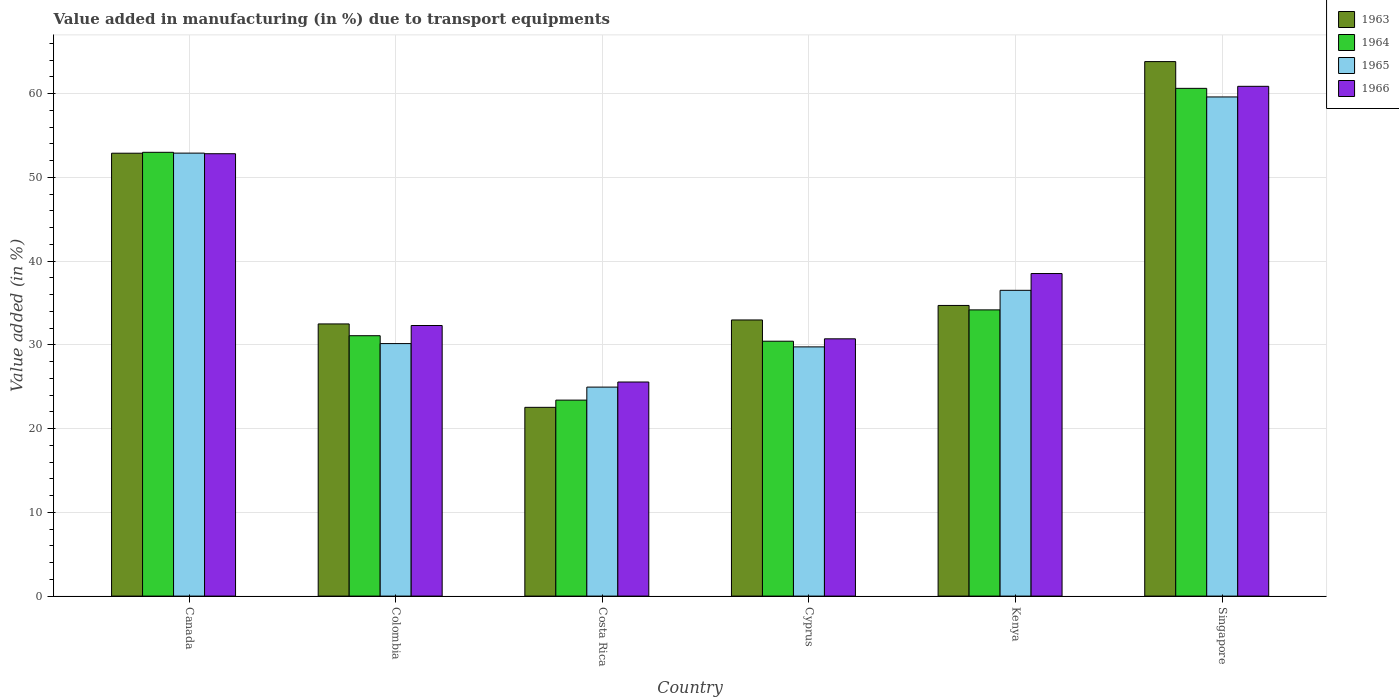How many groups of bars are there?
Your answer should be compact. 6. Are the number of bars per tick equal to the number of legend labels?
Ensure brevity in your answer.  Yes. Are the number of bars on each tick of the X-axis equal?
Your answer should be compact. Yes. How many bars are there on the 6th tick from the left?
Keep it short and to the point. 4. How many bars are there on the 5th tick from the right?
Give a very brief answer. 4. What is the label of the 2nd group of bars from the left?
Your response must be concise. Colombia. What is the percentage of value added in manufacturing due to transport equipments in 1966 in Colombia?
Provide a short and direct response. 32.3. Across all countries, what is the maximum percentage of value added in manufacturing due to transport equipments in 1965?
Keep it short and to the point. 59.59. Across all countries, what is the minimum percentage of value added in manufacturing due to transport equipments in 1963?
Offer a terse response. 22.53. In which country was the percentage of value added in manufacturing due to transport equipments in 1965 maximum?
Give a very brief answer. Singapore. What is the total percentage of value added in manufacturing due to transport equipments in 1966 in the graph?
Offer a very short reply. 240.76. What is the difference between the percentage of value added in manufacturing due to transport equipments in 1966 in Colombia and that in Singapore?
Your answer should be compact. -28.56. What is the difference between the percentage of value added in manufacturing due to transport equipments in 1966 in Costa Rica and the percentage of value added in manufacturing due to transport equipments in 1965 in Singapore?
Provide a short and direct response. -34.03. What is the average percentage of value added in manufacturing due to transport equipments in 1965 per country?
Ensure brevity in your answer.  38.97. What is the difference between the percentage of value added in manufacturing due to transport equipments of/in 1965 and percentage of value added in manufacturing due to transport equipments of/in 1966 in Kenya?
Your answer should be compact. -2. In how many countries, is the percentage of value added in manufacturing due to transport equipments in 1963 greater than 60 %?
Provide a succinct answer. 1. What is the ratio of the percentage of value added in manufacturing due to transport equipments in 1966 in Canada to that in Cyprus?
Keep it short and to the point. 1.72. Is the percentage of value added in manufacturing due to transport equipments in 1963 in Costa Rica less than that in Singapore?
Keep it short and to the point. Yes. What is the difference between the highest and the second highest percentage of value added in manufacturing due to transport equipments in 1963?
Provide a succinct answer. -18.17. What is the difference between the highest and the lowest percentage of value added in manufacturing due to transport equipments in 1965?
Provide a short and direct response. 34.64. In how many countries, is the percentage of value added in manufacturing due to transport equipments in 1965 greater than the average percentage of value added in manufacturing due to transport equipments in 1965 taken over all countries?
Offer a terse response. 2. Is the sum of the percentage of value added in manufacturing due to transport equipments in 1964 in Kenya and Singapore greater than the maximum percentage of value added in manufacturing due to transport equipments in 1963 across all countries?
Keep it short and to the point. Yes. What does the 4th bar from the left in Costa Rica represents?
Offer a terse response. 1966. What does the 3rd bar from the right in Costa Rica represents?
Give a very brief answer. 1964. Are all the bars in the graph horizontal?
Offer a terse response. No. How many countries are there in the graph?
Provide a succinct answer. 6. Are the values on the major ticks of Y-axis written in scientific E-notation?
Your answer should be very brief. No. Does the graph contain any zero values?
Offer a very short reply. No. Does the graph contain grids?
Provide a short and direct response. Yes. How many legend labels are there?
Offer a very short reply. 4. What is the title of the graph?
Provide a short and direct response. Value added in manufacturing (in %) due to transport equipments. Does "1970" appear as one of the legend labels in the graph?
Make the answer very short. No. What is the label or title of the Y-axis?
Give a very brief answer. Value added (in %). What is the Value added (in %) in 1963 in Canada?
Offer a very short reply. 52.87. What is the Value added (in %) of 1964 in Canada?
Your response must be concise. 52.98. What is the Value added (in %) in 1965 in Canada?
Your response must be concise. 52.89. What is the Value added (in %) in 1966 in Canada?
Your answer should be very brief. 52.81. What is the Value added (in %) in 1963 in Colombia?
Provide a succinct answer. 32.49. What is the Value added (in %) in 1964 in Colombia?
Your response must be concise. 31.09. What is the Value added (in %) of 1965 in Colombia?
Provide a short and direct response. 30.15. What is the Value added (in %) in 1966 in Colombia?
Keep it short and to the point. 32.3. What is the Value added (in %) of 1963 in Costa Rica?
Make the answer very short. 22.53. What is the Value added (in %) in 1964 in Costa Rica?
Ensure brevity in your answer.  23.4. What is the Value added (in %) of 1965 in Costa Rica?
Your answer should be very brief. 24.95. What is the Value added (in %) of 1966 in Costa Rica?
Your answer should be compact. 25.56. What is the Value added (in %) of 1963 in Cyprus?
Keep it short and to the point. 32.97. What is the Value added (in %) of 1964 in Cyprus?
Make the answer very short. 30.43. What is the Value added (in %) in 1965 in Cyprus?
Keep it short and to the point. 29.75. What is the Value added (in %) in 1966 in Cyprus?
Your answer should be compact. 30.72. What is the Value added (in %) of 1963 in Kenya?
Give a very brief answer. 34.7. What is the Value added (in %) of 1964 in Kenya?
Your answer should be compact. 34.17. What is the Value added (in %) in 1965 in Kenya?
Your answer should be compact. 36.5. What is the Value added (in %) in 1966 in Kenya?
Give a very brief answer. 38.51. What is the Value added (in %) of 1963 in Singapore?
Your answer should be very brief. 63.81. What is the Value added (in %) of 1964 in Singapore?
Your response must be concise. 60.62. What is the Value added (in %) of 1965 in Singapore?
Your answer should be very brief. 59.59. What is the Value added (in %) of 1966 in Singapore?
Ensure brevity in your answer.  60.86. Across all countries, what is the maximum Value added (in %) in 1963?
Provide a succinct answer. 63.81. Across all countries, what is the maximum Value added (in %) in 1964?
Your response must be concise. 60.62. Across all countries, what is the maximum Value added (in %) in 1965?
Provide a succinct answer. 59.59. Across all countries, what is the maximum Value added (in %) in 1966?
Provide a succinct answer. 60.86. Across all countries, what is the minimum Value added (in %) in 1963?
Offer a very short reply. 22.53. Across all countries, what is the minimum Value added (in %) in 1964?
Your response must be concise. 23.4. Across all countries, what is the minimum Value added (in %) in 1965?
Offer a very short reply. 24.95. Across all countries, what is the minimum Value added (in %) of 1966?
Provide a short and direct response. 25.56. What is the total Value added (in %) of 1963 in the graph?
Keep it short and to the point. 239.38. What is the total Value added (in %) in 1964 in the graph?
Offer a terse response. 232.68. What is the total Value added (in %) of 1965 in the graph?
Make the answer very short. 233.83. What is the total Value added (in %) in 1966 in the graph?
Your answer should be very brief. 240.76. What is the difference between the Value added (in %) in 1963 in Canada and that in Colombia?
Make the answer very short. 20.38. What is the difference between the Value added (in %) of 1964 in Canada and that in Colombia?
Your response must be concise. 21.9. What is the difference between the Value added (in %) in 1965 in Canada and that in Colombia?
Ensure brevity in your answer.  22.74. What is the difference between the Value added (in %) of 1966 in Canada and that in Colombia?
Your response must be concise. 20.51. What is the difference between the Value added (in %) in 1963 in Canada and that in Costa Rica?
Your answer should be very brief. 30.34. What is the difference between the Value added (in %) of 1964 in Canada and that in Costa Rica?
Ensure brevity in your answer.  29.59. What is the difference between the Value added (in %) in 1965 in Canada and that in Costa Rica?
Your answer should be compact. 27.93. What is the difference between the Value added (in %) in 1966 in Canada and that in Costa Rica?
Your response must be concise. 27.25. What is the difference between the Value added (in %) in 1963 in Canada and that in Cyprus?
Offer a terse response. 19.91. What is the difference between the Value added (in %) in 1964 in Canada and that in Cyprus?
Your response must be concise. 22.55. What is the difference between the Value added (in %) in 1965 in Canada and that in Cyprus?
Your answer should be compact. 23.13. What is the difference between the Value added (in %) of 1966 in Canada and that in Cyprus?
Ensure brevity in your answer.  22.1. What is the difference between the Value added (in %) in 1963 in Canada and that in Kenya?
Ensure brevity in your answer.  18.17. What is the difference between the Value added (in %) of 1964 in Canada and that in Kenya?
Offer a very short reply. 18.81. What is the difference between the Value added (in %) in 1965 in Canada and that in Kenya?
Provide a short and direct response. 16.38. What is the difference between the Value added (in %) in 1966 in Canada and that in Kenya?
Your response must be concise. 14.3. What is the difference between the Value added (in %) in 1963 in Canada and that in Singapore?
Your response must be concise. -10.94. What is the difference between the Value added (in %) of 1964 in Canada and that in Singapore?
Your response must be concise. -7.63. What is the difference between the Value added (in %) of 1965 in Canada and that in Singapore?
Give a very brief answer. -6.71. What is the difference between the Value added (in %) of 1966 in Canada and that in Singapore?
Give a very brief answer. -8.05. What is the difference between the Value added (in %) in 1963 in Colombia and that in Costa Rica?
Make the answer very short. 9.96. What is the difference between the Value added (in %) in 1964 in Colombia and that in Costa Rica?
Offer a terse response. 7.69. What is the difference between the Value added (in %) in 1965 in Colombia and that in Costa Rica?
Offer a terse response. 5.2. What is the difference between the Value added (in %) of 1966 in Colombia and that in Costa Rica?
Provide a short and direct response. 6.74. What is the difference between the Value added (in %) of 1963 in Colombia and that in Cyprus?
Make the answer very short. -0.47. What is the difference between the Value added (in %) of 1964 in Colombia and that in Cyprus?
Make the answer very short. 0.66. What is the difference between the Value added (in %) in 1965 in Colombia and that in Cyprus?
Your answer should be very brief. 0.39. What is the difference between the Value added (in %) of 1966 in Colombia and that in Cyprus?
Provide a short and direct response. 1.59. What is the difference between the Value added (in %) in 1963 in Colombia and that in Kenya?
Provide a short and direct response. -2.21. What is the difference between the Value added (in %) of 1964 in Colombia and that in Kenya?
Provide a succinct answer. -3.08. What is the difference between the Value added (in %) of 1965 in Colombia and that in Kenya?
Your response must be concise. -6.36. What is the difference between the Value added (in %) of 1966 in Colombia and that in Kenya?
Make the answer very short. -6.2. What is the difference between the Value added (in %) of 1963 in Colombia and that in Singapore?
Make the answer very short. -31.32. What is the difference between the Value added (in %) in 1964 in Colombia and that in Singapore?
Provide a succinct answer. -29.53. What is the difference between the Value added (in %) of 1965 in Colombia and that in Singapore?
Offer a terse response. -29.45. What is the difference between the Value added (in %) in 1966 in Colombia and that in Singapore?
Ensure brevity in your answer.  -28.56. What is the difference between the Value added (in %) of 1963 in Costa Rica and that in Cyprus?
Provide a succinct answer. -10.43. What is the difference between the Value added (in %) in 1964 in Costa Rica and that in Cyprus?
Offer a terse response. -7.03. What is the difference between the Value added (in %) of 1965 in Costa Rica and that in Cyprus?
Provide a short and direct response. -4.8. What is the difference between the Value added (in %) of 1966 in Costa Rica and that in Cyprus?
Give a very brief answer. -5.16. What is the difference between the Value added (in %) in 1963 in Costa Rica and that in Kenya?
Your answer should be compact. -12.17. What is the difference between the Value added (in %) of 1964 in Costa Rica and that in Kenya?
Offer a very short reply. -10.77. What is the difference between the Value added (in %) of 1965 in Costa Rica and that in Kenya?
Your answer should be compact. -11.55. What is the difference between the Value added (in %) in 1966 in Costa Rica and that in Kenya?
Offer a very short reply. -12.95. What is the difference between the Value added (in %) of 1963 in Costa Rica and that in Singapore?
Your answer should be very brief. -41.28. What is the difference between the Value added (in %) in 1964 in Costa Rica and that in Singapore?
Your answer should be compact. -37.22. What is the difference between the Value added (in %) of 1965 in Costa Rica and that in Singapore?
Your response must be concise. -34.64. What is the difference between the Value added (in %) in 1966 in Costa Rica and that in Singapore?
Give a very brief answer. -35.3. What is the difference between the Value added (in %) of 1963 in Cyprus and that in Kenya?
Make the answer very short. -1.73. What is the difference between the Value added (in %) in 1964 in Cyprus and that in Kenya?
Provide a short and direct response. -3.74. What is the difference between the Value added (in %) of 1965 in Cyprus and that in Kenya?
Your answer should be compact. -6.75. What is the difference between the Value added (in %) in 1966 in Cyprus and that in Kenya?
Ensure brevity in your answer.  -7.79. What is the difference between the Value added (in %) in 1963 in Cyprus and that in Singapore?
Offer a terse response. -30.84. What is the difference between the Value added (in %) in 1964 in Cyprus and that in Singapore?
Keep it short and to the point. -30.19. What is the difference between the Value added (in %) of 1965 in Cyprus and that in Singapore?
Your response must be concise. -29.84. What is the difference between the Value added (in %) in 1966 in Cyprus and that in Singapore?
Provide a succinct answer. -30.14. What is the difference between the Value added (in %) in 1963 in Kenya and that in Singapore?
Offer a terse response. -29.11. What is the difference between the Value added (in %) of 1964 in Kenya and that in Singapore?
Provide a short and direct response. -26.45. What is the difference between the Value added (in %) in 1965 in Kenya and that in Singapore?
Provide a short and direct response. -23.09. What is the difference between the Value added (in %) of 1966 in Kenya and that in Singapore?
Offer a terse response. -22.35. What is the difference between the Value added (in %) in 1963 in Canada and the Value added (in %) in 1964 in Colombia?
Provide a succinct answer. 21.79. What is the difference between the Value added (in %) in 1963 in Canada and the Value added (in %) in 1965 in Colombia?
Your answer should be compact. 22.73. What is the difference between the Value added (in %) of 1963 in Canada and the Value added (in %) of 1966 in Colombia?
Your response must be concise. 20.57. What is the difference between the Value added (in %) of 1964 in Canada and the Value added (in %) of 1965 in Colombia?
Your answer should be compact. 22.84. What is the difference between the Value added (in %) of 1964 in Canada and the Value added (in %) of 1966 in Colombia?
Your answer should be very brief. 20.68. What is the difference between the Value added (in %) of 1965 in Canada and the Value added (in %) of 1966 in Colombia?
Keep it short and to the point. 20.58. What is the difference between the Value added (in %) in 1963 in Canada and the Value added (in %) in 1964 in Costa Rica?
Give a very brief answer. 29.48. What is the difference between the Value added (in %) of 1963 in Canada and the Value added (in %) of 1965 in Costa Rica?
Keep it short and to the point. 27.92. What is the difference between the Value added (in %) in 1963 in Canada and the Value added (in %) in 1966 in Costa Rica?
Provide a succinct answer. 27.31. What is the difference between the Value added (in %) in 1964 in Canada and the Value added (in %) in 1965 in Costa Rica?
Provide a succinct answer. 28.03. What is the difference between the Value added (in %) of 1964 in Canada and the Value added (in %) of 1966 in Costa Rica?
Your response must be concise. 27.42. What is the difference between the Value added (in %) in 1965 in Canada and the Value added (in %) in 1966 in Costa Rica?
Offer a very short reply. 27.33. What is the difference between the Value added (in %) of 1963 in Canada and the Value added (in %) of 1964 in Cyprus?
Offer a very short reply. 22.44. What is the difference between the Value added (in %) of 1963 in Canada and the Value added (in %) of 1965 in Cyprus?
Your answer should be compact. 23.12. What is the difference between the Value added (in %) of 1963 in Canada and the Value added (in %) of 1966 in Cyprus?
Provide a succinct answer. 22.16. What is the difference between the Value added (in %) in 1964 in Canada and the Value added (in %) in 1965 in Cyprus?
Ensure brevity in your answer.  23.23. What is the difference between the Value added (in %) in 1964 in Canada and the Value added (in %) in 1966 in Cyprus?
Offer a very short reply. 22.27. What is the difference between the Value added (in %) of 1965 in Canada and the Value added (in %) of 1966 in Cyprus?
Give a very brief answer. 22.17. What is the difference between the Value added (in %) in 1963 in Canada and the Value added (in %) in 1964 in Kenya?
Your response must be concise. 18.7. What is the difference between the Value added (in %) of 1963 in Canada and the Value added (in %) of 1965 in Kenya?
Provide a succinct answer. 16.37. What is the difference between the Value added (in %) in 1963 in Canada and the Value added (in %) in 1966 in Kenya?
Give a very brief answer. 14.37. What is the difference between the Value added (in %) of 1964 in Canada and the Value added (in %) of 1965 in Kenya?
Make the answer very short. 16.48. What is the difference between the Value added (in %) of 1964 in Canada and the Value added (in %) of 1966 in Kenya?
Ensure brevity in your answer.  14.47. What is the difference between the Value added (in %) of 1965 in Canada and the Value added (in %) of 1966 in Kenya?
Your response must be concise. 14.38. What is the difference between the Value added (in %) of 1963 in Canada and the Value added (in %) of 1964 in Singapore?
Ensure brevity in your answer.  -7.74. What is the difference between the Value added (in %) in 1963 in Canada and the Value added (in %) in 1965 in Singapore?
Keep it short and to the point. -6.72. What is the difference between the Value added (in %) of 1963 in Canada and the Value added (in %) of 1966 in Singapore?
Ensure brevity in your answer.  -7.99. What is the difference between the Value added (in %) of 1964 in Canada and the Value added (in %) of 1965 in Singapore?
Your response must be concise. -6.61. What is the difference between the Value added (in %) in 1964 in Canada and the Value added (in %) in 1966 in Singapore?
Provide a short and direct response. -7.88. What is the difference between the Value added (in %) of 1965 in Canada and the Value added (in %) of 1966 in Singapore?
Offer a very short reply. -7.97. What is the difference between the Value added (in %) in 1963 in Colombia and the Value added (in %) in 1964 in Costa Rica?
Your response must be concise. 9.1. What is the difference between the Value added (in %) in 1963 in Colombia and the Value added (in %) in 1965 in Costa Rica?
Give a very brief answer. 7.54. What is the difference between the Value added (in %) in 1963 in Colombia and the Value added (in %) in 1966 in Costa Rica?
Keep it short and to the point. 6.93. What is the difference between the Value added (in %) of 1964 in Colombia and the Value added (in %) of 1965 in Costa Rica?
Keep it short and to the point. 6.14. What is the difference between the Value added (in %) of 1964 in Colombia and the Value added (in %) of 1966 in Costa Rica?
Your answer should be compact. 5.53. What is the difference between the Value added (in %) in 1965 in Colombia and the Value added (in %) in 1966 in Costa Rica?
Make the answer very short. 4.59. What is the difference between the Value added (in %) of 1963 in Colombia and the Value added (in %) of 1964 in Cyprus?
Ensure brevity in your answer.  2.06. What is the difference between the Value added (in %) in 1963 in Colombia and the Value added (in %) in 1965 in Cyprus?
Ensure brevity in your answer.  2.74. What is the difference between the Value added (in %) in 1963 in Colombia and the Value added (in %) in 1966 in Cyprus?
Make the answer very short. 1.78. What is the difference between the Value added (in %) of 1964 in Colombia and the Value added (in %) of 1965 in Cyprus?
Make the answer very short. 1.33. What is the difference between the Value added (in %) of 1964 in Colombia and the Value added (in %) of 1966 in Cyprus?
Ensure brevity in your answer.  0.37. What is the difference between the Value added (in %) in 1965 in Colombia and the Value added (in %) in 1966 in Cyprus?
Your answer should be very brief. -0.57. What is the difference between the Value added (in %) in 1963 in Colombia and the Value added (in %) in 1964 in Kenya?
Provide a short and direct response. -1.68. What is the difference between the Value added (in %) of 1963 in Colombia and the Value added (in %) of 1965 in Kenya?
Give a very brief answer. -4.01. What is the difference between the Value added (in %) in 1963 in Colombia and the Value added (in %) in 1966 in Kenya?
Provide a short and direct response. -6.01. What is the difference between the Value added (in %) of 1964 in Colombia and the Value added (in %) of 1965 in Kenya?
Provide a succinct answer. -5.42. What is the difference between the Value added (in %) in 1964 in Colombia and the Value added (in %) in 1966 in Kenya?
Offer a terse response. -7.42. What is the difference between the Value added (in %) of 1965 in Colombia and the Value added (in %) of 1966 in Kenya?
Provide a short and direct response. -8.36. What is the difference between the Value added (in %) of 1963 in Colombia and the Value added (in %) of 1964 in Singapore?
Your response must be concise. -28.12. What is the difference between the Value added (in %) in 1963 in Colombia and the Value added (in %) in 1965 in Singapore?
Keep it short and to the point. -27.1. What is the difference between the Value added (in %) of 1963 in Colombia and the Value added (in %) of 1966 in Singapore?
Keep it short and to the point. -28.37. What is the difference between the Value added (in %) in 1964 in Colombia and the Value added (in %) in 1965 in Singapore?
Offer a very short reply. -28.51. What is the difference between the Value added (in %) in 1964 in Colombia and the Value added (in %) in 1966 in Singapore?
Your response must be concise. -29.77. What is the difference between the Value added (in %) of 1965 in Colombia and the Value added (in %) of 1966 in Singapore?
Offer a very short reply. -30.71. What is the difference between the Value added (in %) of 1963 in Costa Rica and the Value added (in %) of 1964 in Cyprus?
Your answer should be very brief. -7.9. What is the difference between the Value added (in %) in 1963 in Costa Rica and the Value added (in %) in 1965 in Cyprus?
Offer a terse response. -7.22. What is the difference between the Value added (in %) of 1963 in Costa Rica and the Value added (in %) of 1966 in Cyprus?
Your response must be concise. -8.18. What is the difference between the Value added (in %) of 1964 in Costa Rica and the Value added (in %) of 1965 in Cyprus?
Offer a very short reply. -6.36. What is the difference between the Value added (in %) of 1964 in Costa Rica and the Value added (in %) of 1966 in Cyprus?
Your response must be concise. -7.32. What is the difference between the Value added (in %) of 1965 in Costa Rica and the Value added (in %) of 1966 in Cyprus?
Your answer should be very brief. -5.77. What is the difference between the Value added (in %) in 1963 in Costa Rica and the Value added (in %) in 1964 in Kenya?
Ensure brevity in your answer.  -11.64. What is the difference between the Value added (in %) in 1963 in Costa Rica and the Value added (in %) in 1965 in Kenya?
Your answer should be compact. -13.97. What is the difference between the Value added (in %) of 1963 in Costa Rica and the Value added (in %) of 1966 in Kenya?
Keep it short and to the point. -15.97. What is the difference between the Value added (in %) in 1964 in Costa Rica and the Value added (in %) in 1965 in Kenya?
Make the answer very short. -13.11. What is the difference between the Value added (in %) in 1964 in Costa Rica and the Value added (in %) in 1966 in Kenya?
Keep it short and to the point. -15.11. What is the difference between the Value added (in %) of 1965 in Costa Rica and the Value added (in %) of 1966 in Kenya?
Your response must be concise. -13.56. What is the difference between the Value added (in %) in 1963 in Costa Rica and the Value added (in %) in 1964 in Singapore?
Offer a terse response. -38.08. What is the difference between the Value added (in %) of 1963 in Costa Rica and the Value added (in %) of 1965 in Singapore?
Make the answer very short. -37.06. What is the difference between the Value added (in %) of 1963 in Costa Rica and the Value added (in %) of 1966 in Singapore?
Provide a short and direct response. -38.33. What is the difference between the Value added (in %) of 1964 in Costa Rica and the Value added (in %) of 1965 in Singapore?
Give a very brief answer. -36.19. What is the difference between the Value added (in %) of 1964 in Costa Rica and the Value added (in %) of 1966 in Singapore?
Your answer should be compact. -37.46. What is the difference between the Value added (in %) in 1965 in Costa Rica and the Value added (in %) in 1966 in Singapore?
Give a very brief answer. -35.91. What is the difference between the Value added (in %) in 1963 in Cyprus and the Value added (in %) in 1964 in Kenya?
Make the answer very short. -1.2. What is the difference between the Value added (in %) of 1963 in Cyprus and the Value added (in %) of 1965 in Kenya?
Give a very brief answer. -3.54. What is the difference between the Value added (in %) of 1963 in Cyprus and the Value added (in %) of 1966 in Kenya?
Your answer should be very brief. -5.54. What is the difference between the Value added (in %) of 1964 in Cyprus and the Value added (in %) of 1965 in Kenya?
Provide a succinct answer. -6.07. What is the difference between the Value added (in %) in 1964 in Cyprus and the Value added (in %) in 1966 in Kenya?
Offer a very short reply. -8.08. What is the difference between the Value added (in %) in 1965 in Cyprus and the Value added (in %) in 1966 in Kenya?
Offer a very short reply. -8.75. What is the difference between the Value added (in %) of 1963 in Cyprus and the Value added (in %) of 1964 in Singapore?
Offer a terse response. -27.65. What is the difference between the Value added (in %) in 1963 in Cyprus and the Value added (in %) in 1965 in Singapore?
Make the answer very short. -26.62. What is the difference between the Value added (in %) of 1963 in Cyprus and the Value added (in %) of 1966 in Singapore?
Your answer should be very brief. -27.89. What is the difference between the Value added (in %) of 1964 in Cyprus and the Value added (in %) of 1965 in Singapore?
Your answer should be very brief. -29.16. What is the difference between the Value added (in %) in 1964 in Cyprus and the Value added (in %) in 1966 in Singapore?
Your answer should be compact. -30.43. What is the difference between the Value added (in %) in 1965 in Cyprus and the Value added (in %) in 1966 in Singapore?
Keep it short and to the point. -31.11. What is the difference between the Value added (in %) of 1963 in Kenya and the Value added (in %) of 1964 in Singapore?
Your answer should be compact. -25.92. What is the difference between the Value added (in %) of 1963 in Kenya and the Value added (in %) of 1965 in Singapore?
Provide a succinct answer. -24.89. What is the difference between the Value added (in %) of 1963 in Kenya and the Value added (in %) of 1966 in Singapore?
Give a very brief answer. -26.16. What is the difference between the Value added (in %) of 1964 in Kenya and the Value added (in %) of 1965 in Singapore?
Ensure brevity in your answer.  -25.42. What is the difference between the Value added (in %) in 1964 in Kenya and the Value added (in %) in 1966 in Singapore?
Ensure brevity in your answer.  -26.69. What is the difference between the Value added (in %) in 1965 in Kenya and the Value added (in %) in 1966 in Singapore?
Your answer should be compact. -24.36. What is the average Value added (in %) in 1963 per country?
Give a very brief answer. 39.9. What is the average Value added (in %) of 1964 per country?
Give a very brief answer. 38.78. What is the average Value added (in %) of 1965 per country?
Offer a very short reply. 38.97. What is the average Value added (in %) in 1966 per country?
Offer a terse response. 40.13. What is the difference between the Value added (in %) of 1963 and Value added (in %) of 1964 in Canada?
Your answer should be compact. -0.11. What is the difference between the Value added (in %) of 1963 and Value added (in %) of 1965 in Canada?
Provide a succinct answer. -0.01. What is the difference between the Value added (in %) in 1963 and Value added (in %) in 1966 in Canada?
Ensure brevity in your answer.  0.06. What is the difference between the Value added (in %) in 1964 and Value added (in %) in 1965 in Canada?
Provide a succinct answer. 0.1. What is the difference between the Value added (in %) in 1964 and Value added (in %) in 1966 in Canada?
Offer a very short reply. 0.17. What is the difference between the Value added (in %) of 1965 and Value added (in %) of 1966 in Canada?
Offer a terse response. 0.07. What is the difference between the Value added (in %) in 1963 and Value added (in %) in 1964 in Colombia?
Your answer should be very brief. 1.41. What is the difference between the Value added (in %) of 1963 and Value added (in %) of 1965 in Colombia?
Give a very brief answer. 2.35. What is the difference between the Value added (in %) of 1963 and Value added (in %) of 1966 in Colombia?
Provide a succinct answer. 0.19. What is the difference between the Value added (in %) in 1964 and Value added (in %) in 1965 in Colombia?
Provide a succinct answer. 0.94. What is the difference between the Value added (in %) of 1964 and Value added (in %) of 1966 in Colombia?
Your response must be concise. -1.22. What is the difference between the Value added (in %) of 1965 and Value added (in %) of 1966 in Colombia?
Offer a terse response. -2.16. What is the difference between the Value added (in %) in 1963 and Value added (in %) in 1964 in Costa Rica?
Offer a very short reply. -0.86. What is the difference between the Value added (in %) of 1963 and Value added (in %) of 1965 in Costa Rica?
Give a very brief answer. -2.42. What is the difference between the Value added (in %) of 1963 and Value added (in %) of 1966 in Costa Rica?
Your response must be concise. -3.03. What is the difference between the Value added (in %) in 1964 and Value added (in %) in 1965 in Costa Rica?
Make the answer very short. -1.55. What is the difference between the Value added (in %) in 1964 and Value added (in %) in 1966 in Costa Rica?
Offer a terse response. -2.16. What is the difference between the Value added (in %) in 1965 and Value added (in %) in 1966 in Costa Rica?
Your answer should be very brief. -0.61. What is the difference between the Value added (in %) of 1963 and Value added (in %) of 1964 in Cyprus?
Your answer should be compact. 2.54. What is the difference between the Value added (in %) in 1963 and Value added (in %) in 1965 in Cyprus?
Give a very brief answer. 3.21. What is the difference between the Value added (in %) of 1963 and Value added (in %) of 1966 in Cyprus?
Provide a succinct answer. 2.25. What is the difference between the Value added (in %) of 1964 and Value added (in %) of 1965 in Cyprus?
Offer a terse response. 0.68. What is the difference between the Value added (in %) of 1964 and Value added (in %) of 1966 in Cyprus?
Offer a very short reply. -0.29. What is the difference between the Value added (in %) in 1965 and Value added (in %) in 1966 in Cyprus?
Provide a short and direct response. -0.96. What is the difference between the Value added (in %) in 1963 and Value added (in %) in 1964 in Kenya?
Provide a succinct answer. 0.53. What is the difference between the Value added (in %) of 1963 and Value added (in %) of 1965 in Kenya?
Your response must be concise. -1.8. What is the difference between the Value added (in %) in 1963 and Value added (in %) in 1966 in Kenya?
Your response must be concise. -3.81. What is the difference between the Value added (in %) of 1964 and Value added (in %) of 1965 in Kenya?
Your answer should be compact. -2.33. What is the difference between the Value added (in %) of 1964 and Value added (in %) of 1966 in Kenya?
Make the answer very short. -4.34. What is the difference between the Value added (in %) in 1965 and Value added (in %) in 1966 in Kenya?
Your answer should be compact. -2. What is the difference between the Value added (in %) in 1963 and Value added (in %) in 1964 in Singapore?
Offer a very short reply. 3.19. What is the difference between the Value added (in %) of 1963 and Value added (in %) of 1965 in Singapore?
Provide a succinct answer. 4.22. What is the difference between the Value added (in %) in 1963 and Value added (in %) in 1966 in Singapore?
Provide a succinct answer. 2.95. What is the difference between the Value added (in %) in 1964 and Value added (in %) in 1965 in Singapore?
Give a very brief answer. 1.03. What is the difference between the Value added (in %) of 1964 and Value added (in %) of 1966 in Singapore?
Your answer should be very brief. -0.24. What is the difference between the Value added (in %) in 1965 and Value added (in %) in 1966 in Singapore?
Your response must be concise. -1.27. What is the ratio of the Value added (in %) in 1963 in Canada to that in Colombia?
Keep it short and to the point. 1.63. What is the ratio of the Value added (in %) of 1964 in Canada to that in Colombia?
Your answer should be very brief. 1.7. What is the ratio of the Value added (in %) of 1965 in Canada to that in Colombia?
Keep it short and to the point. 1.75. What is the ratio of the Value added (in %) of 1966 in Canada to that in Colombia?
Provide a short and direct response. 1.63. What is the ratio of the Value added (in %) of 1963 in Canada to that in Costa Rica?
Your answer should be compact. 2.35. What is the ratio of the Value added (in %) of 1964 in Canada to that in Costa Rica?
Your response must be concise. 2.26. What is the ratio of the Value added (in %) of 1965 in Canada to that in Costa Rica?
Provide a short and direct response. 2.12. What is the ratio of the Value added (in %) of 1966 in Canada to that in Costa Rica?
Your answer should be compact. 2.07. What is the ratio of the Value added (in %) in 1963 in Canada to that in Cyprus?
Provide a short and direct response. 1.6. What is the ratio of the Value added (in %) in 1964 in Canada to that in Cyprus?
Ensure brevity in your answer.  1.74. What is the ratio of the Value added (in %) of 1965 in Canada to that in Cyprus?
Your response must be concise. 1.78. What is the ratio of the Value added (in %) of 1966 in Canada to that in Cyprus?
Offer a terse response. 1.72. What is the ratio of the Value added (in %) in 1963 in Canada to that in Kenya?
Offer a terse response. 1.52. What is the ratio of the Value added (in %) in 1964 in Canada to that in Kenya?
Make the answer very short. 1.55. What is the ratio of the Value added (in %) in 1965 in Canada to that in Kenya?
Your answer should be very brief. 1.45. What is the ratio of the Value added (in %) of 1966 in Canada to that in Kenya?
Make the answer very short. 1.37. What is the ratio of the Value added (in %) of 1963 in Canada to that in Singapore?
Your answer should be compact. 0.83. What is the ratio of the Value added (in %) in 1964 in Canada to that in Singapore?
Your answer should be very brief. 0.87. What is the ratio of the Value added (in %) in 1965 in Canada to that in Singapore?
Your response must be concise. 0.89. What is the ratio of the Value added (in %) of 1966 in Canada to that in Singapore?
Provide a succinct answer. 0.87. What is the ratio of the Value added (in %) of 1963 in Colombia to that in Costa Rica?
Keep it short and to the point. 1.44. What is the ratio of the Value added (in %) of 1964 in Colombia to that in Costa Rica?
Give a very brief answer. 1.33. What is the ratio of the Value added (in %) in 1965 in Colombia to that in Costa Rica?
Offer a very short reply. 1.21. What is the ratio of the Value added (in %) in 1966 in Colombia to that in Costa Rica?
Provide a short and direct response. 1.26. What is the ratio of the Value added (in %) of 1963 in Colombia to that in Cyprus?
Ensure brevity in your answer.  0.99. What is the ratio of the Value added (in %) in 1964 in Colombia to that in Cyprus?
Make the answer very short. 1.02. What is the ratio of the Value added (in %) of 1965 in Colombia to that in Cyprus?
Ensure brevity in your answer.  1.01. What is the ratio of the Value added (in %) in 1966 in Colombia to that in Cyprus?
Keep it short and to the point. 1.05. What is the ratio of the Value added (in %) in 1963 in Colombia to that in Kenya?
Keep it short and to the point. 0.94. What is the ratio of the Value added (in %) of 1964 in Colombia to that in Kenya?
Offer a terse response. 0.91. What is the ratio of the Value added (in %) in 1965 in Colombia to that in Kenya?
Keep it short and to the point. 0.83. What is the ratio of the Value added (in %) in 1966 in Colombia to that in Kenya?
Offer a terse response. 0.84. What is the ratio of the Value added (in %) in 1963 in Colombia to that in Singapore?
Your answer should be compact. 0.51. What is the ratio of the Value added (in %) in 1964 in Colombia to that in Singapore?
Your answer should be compact. 0.51. What is the ratio of the Value added (in %) in 1965 in Colombia to that in Singapore?
Provide a succinct answer. 0.51. What is the ratio of the Value added (in %) in 1966 in Colombia to that in Singapore?
Your answer should be compact. 0.53. What is the ratio of the Value added (in %) of 1963 in Costa Rica to that in Cyprus?
Your response must be concise. 0.68. What is the ratio of the Value added (in %) in 1964 in Costa Rica to that in Cyprus?
Provide a short and direct response. 0.77. What is the ratio of the Value added (in %) in 1965 in Costa Rica to that in Cyprus?
Give a very brief answer. 0.84. What is the ratio of the Value added (in %) of 1966 in Costa Rica to that in Cyprus?
Your answer should be very brief. 0.83. What is the ratio of the Value added (in %) of 1963 in Costa Rica to that in Kenya?
Your answer should be very brief. 0.65. What is the ratio of the Value added (in %) of 1964 in Costa Rica to that in Kenya?
Ensure brevity in your answer.  0.68. What is the ratio of the Value added (in %) in 1965 in Costa Rica to that in Kenya?
Your answer should be compact. 0.68. What is the ratio of the Value added (in %) in 1966 in Costa Rica to that in Kenya?
Offer a very short reply. 0.66. What is the ratio of the Value added (in %) of 1963 in Costa Rica to that in Singapore?
Provide a succinct answer. 0.35. What is the ratio of the Value added (in %) in 1964 in Costa Rica to that in Singapore?
Provide a short and direct response. 0.39. What is the ratio of the Value added (in %) of 1965 in Costa Rica to that in Singapore?
Your response must be concise. 0.42. What is the ratio of the Value added (in %) of 1966 in Costa Rica to that in Singapore?
Your answer should be compact. 0.42. What is the ratio of the Value added (in %) in 1963 in Cyprus to that in Kenya?
Keep it short and to the point. 0.95. What is the ratio of the Value added (in %) of 1964 in Cyprus to that in Kenya?
Your answer should be very brief. 0.89. What is the ratio of the Value added (in %) in 1965 in Cyprus to that in Kenya?
Offer a very short reply. 0.82. What is the ratio of the Value added (in %) in 1966 in Cyprus to that in Kenya?
Ensure brevity in your answer.  0.8. What is the ratio of the Value added (in %) of 1963 in Cyprus to that in Singapore?
Offer a terse response. 0.52. What is the ratio of the Value added (in %) of 1964 in Cyprus to that in Singapore?
Make the answer very short. 0.5. What is the ratio of the Value added (in %) in 1965 in Cyprus to that in Singapore?
Offer a very short reply. 0.5. What is the ratio of the Value added (in %) of 1966 in Cyprus to that in Singapore?
Offer a terse response. 0.5. What is the ratio of the Value added (in %) of 1963 in Kenya to that in Singapore?
Your answer should be very brief. 0.54. What is the ratio of the Value added (in %) in 1964 in Kenya to that in Singapore?
Offer a terse response. 0.56. What is the ratio of the Value added (in %) of 1965 in Kenya to that in Singapore?
Keep it short and to the point. 0.61. What is the ratio of the Value added (in %) of 1966 in Kenya to that in Singapore?
Make the answer very short. 0.63. What is the difference between the highest and the second highest Value added (in %) of 1963?
Your answer should be compact. 10.94. What is the difference between the highest and the second highest Value added (in %) of 1964?
Ensure brevity in your answer.  7.63. What is the difference between the highest and the second highest Value added (in %) in 1965?
Make the answer very short. 6.71. What is the difference between the highest and the second highest Value added (in %) in 1966?
Your answer should be very brief. 8.05. What is the difference between the highest and the lowest Value added (in %) of 1963?
Provide a succinct answer. 41.28. What is the difference between the highest and the lowest Value added (in %) in 1964?
Make the answer very short. 37.22. What is the difference between the highest and the lowest Value added (in %) of 1965?
Your answer should be compact. 34.64. What is the difference between the highest and the lowest Value added (in %) in 1966?
Your response must be concise. 35.3. 